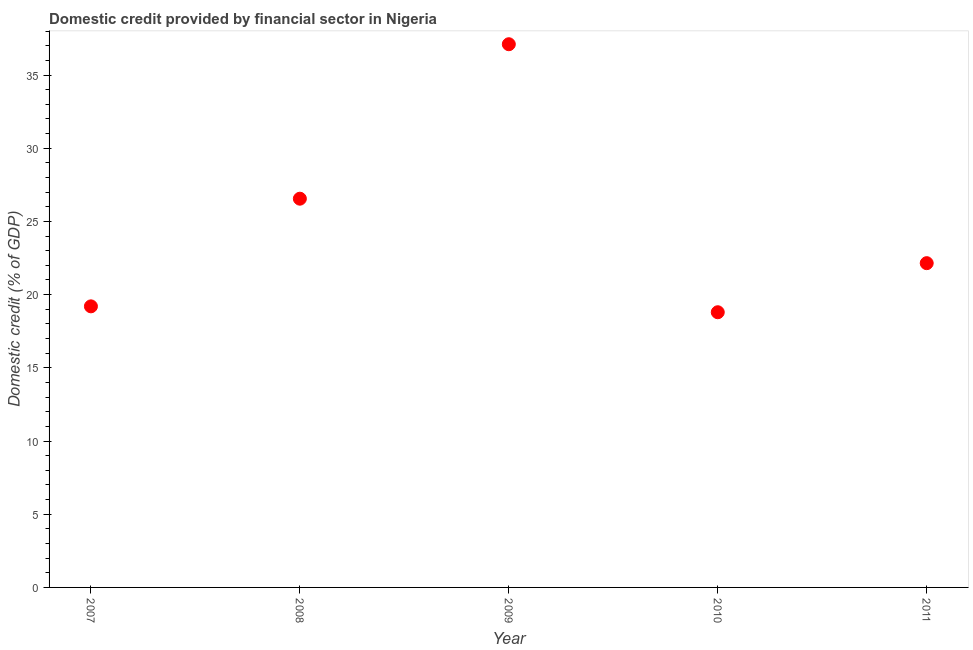What is the domestic credit provided by financial sector in 2009?
Offer a terse response. 37.11. Across all years, what is the maximum domestic credit provided by financial sector?
Your answer should be very brief. 37.11. Across all years, what is the minimum domestic credit provided by financial sector?
Your answer should be compact. 18.8. In which year was the domestic credit provided by financial sector maximum?
Your response must be concise. 2009. What is the sum of the domestic credit provided by financial sector?
Provide a succinct answer. 123.81. What is the difference between the domestic credit provided by financial sector in 2008 and 2011?
Give a very brief answer. 4.4. What is the average domestic credit provided by financial sector per year?
Offer a very short reply. 24.76. What is the median domestic credit provided by financial sector?
Your answer should be very brief. 22.15. Do a majority of the years between 2007 and 2008 (inclusive) have domestic credit provided by financial sector greater than 3 %?
Your response must be concise. Yes. What is the ratio of the domestic credit provided by financial sector in 2007 to that in 2010?
Provide a succinct answer. 1.02. Is the domestic credit provided by financial sector in 2007 less than that in 2011?
Your answer should be very brief. Yes. Is the difference between the domestic credit provided by financial sector in 2008 and 2011 greater than the difference between any two years?
Offer a terse response. No. What is the difference between the highest and the second highest domestic credit provided by financial sector?
Make the answer very short. 10.55. Is the sum of the domestic credit provided by financial sector in 2007 and 2008 greater than the maximum domestic credit provided by financial sector across all years?
Give a very brief answer. Yes. What is the difference between the highest and the lowest domestic credit provided by financial sector?
Offer a very short reply. 18.31. In how many years, is the domestic credit provided by financial sector greater than the average domestic credit provided by financial sector taken over all years?
Provide a short and direct response. 2. Does the domestic credit provided by financial sector monotonically increase over the years?
Offer a very short reply. No. How many years are there in the graph?
Offer a very short reply. 5. What is the difference between two consecutive major ticks on the Y-axis?
Provide a short and direct response. 5. Are the values on the major ticks of Y-axis written in scientific E-notation?
Give a very brief answer. No. What is the title of the graph?
Your answer should be compact. Domestic credit provided by financial sector in Nigeria. What is the label or title of the X-axis?
Your answer should be compact. Year. What is the label or title of the Y-axis?
Your answer should be compact. Domestic credit (% of GDP). What is the Domestic credit (% of GDP) in 2007?
Ensure brevity in your answer.  19.2. What is the Domestic credit (% of GDP) in 2008?
Keep it short and to the point. 26.55. What is the Domestic credit (% of GDP) in 2009?
Offer a very short reply. 37.11. What is the Domestic credit (% of GDP) in 2010?
Provide a succinct answer. 18.8. What is the Domestic credit (% of GDP) in 2011?
Ensure brevity in your answer.  22.15. What is the difference between the Domestic credit (% of GDP) in 2007 and 2008?
Your response must be concise. -7.35. What is the difference between the Domestic credit (% of GDP) in 2007 and 2009?
Ensure brevity in your answer.  -17.91. What is the difference between the Domestic credit (% of GDP) in 2007 and 2010?
Your response must be concise. 0.4. What is the difference between the Domestic credit (% of GDP) in 2007 and 2011?
Give a very brief answer. -2.95. What is the difference between the Domestic credit (% of GDP) in 2008 and 2009?
Provide a short and direct response. -10.55. What is the difference between the Domestic credit (% of GDP) in 2008 and 2010?
Ensure brevity in your answer.  7.76. What is the difference between the Domestic credit (% of GDP) in 2008 and 2011?
Your response must be concise. 4.4. What is the difference between the Domestic credit (% of GDP) in 2009 and 2010?
Make the answer very short. 18.31. What is the difference between the Domestic credit (% of GDP) in 2009 and 2011?
Your answer should be compact. 14.96. What is the difference between the Domestic credit (% of GDP) in 2010 and 2011?
Give a very brief answer. -3.35. What is the ratio of the Domestic credit (% of GDP) in 2007 to that in 2008?
Your answer should be very brief. 0.72. What is the ratio of the Domestic credit (% of GDP) in 2007 to that in 2009?
Offer a very short reply. 0.52. What is the ratio of the Domestic credit (% of GDP) in 2007 to that in 2010?
Give a very brief answer. 1.02. What is the ratio of the Domestic credit (% of GDP) in 2007 to that in 2011?
Your response must be concise. 0.87. What is the ratio of the Domestic credit (% of GDP) in 2008 to that in 2009?
Keep it short and to the point. 0.72. What is the ratio of the Domestic credit (% of GDP) in 2008 to that in 2010?
Provide a succinct answer. 1.41. What is the ratio of the Domestic credit (% of GDP) in 2008 to that in 2011?
Offer a very short reply. 1.2. What is the ratio of the Domestic credit (% of GDP) in 2009 to that in 2010?
Make the answer very short. 1.97. What is the ratio of the Domestic credit (% of GDP) in 2009 to that in 2011?
Provide a short and direct response. 1.68. What is the ratio of the Domestic credit (% of GDP) in 2010 to that in 2011?
Provide a succinct answer. 0.85. 